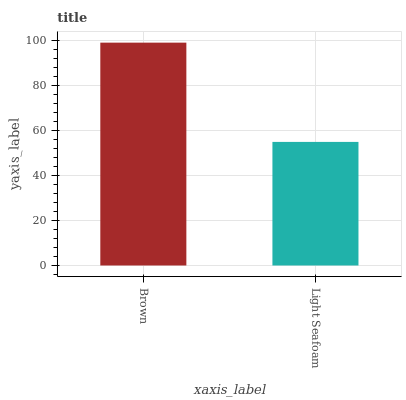Is Light Seafoam the minimum?
Answer yes or no. Yes. Is Brown the maximum?
Answer yes or no. Yes. Is Light Seafoam the maximum?
Answer yes or no. No. Is Brown greater than Light Seafoam?
Answer yes or no. Yes. Is Light Seafoam less than Brown?
Answer yes or no. Yes. Is Light Seafoam greater than Brown?
Answer yes or no. No. Is Brown less than Light Seafoam?
Answer yes or no. No. Is Brown the high median?
Answer yes or no. Yes. Is Light Seafoam the low median?
Answer yes or no. Yes. Is Light Seafoam the high median?
Answer yes or no. No. Is Brown the low median?
Answer yes or no. No. 